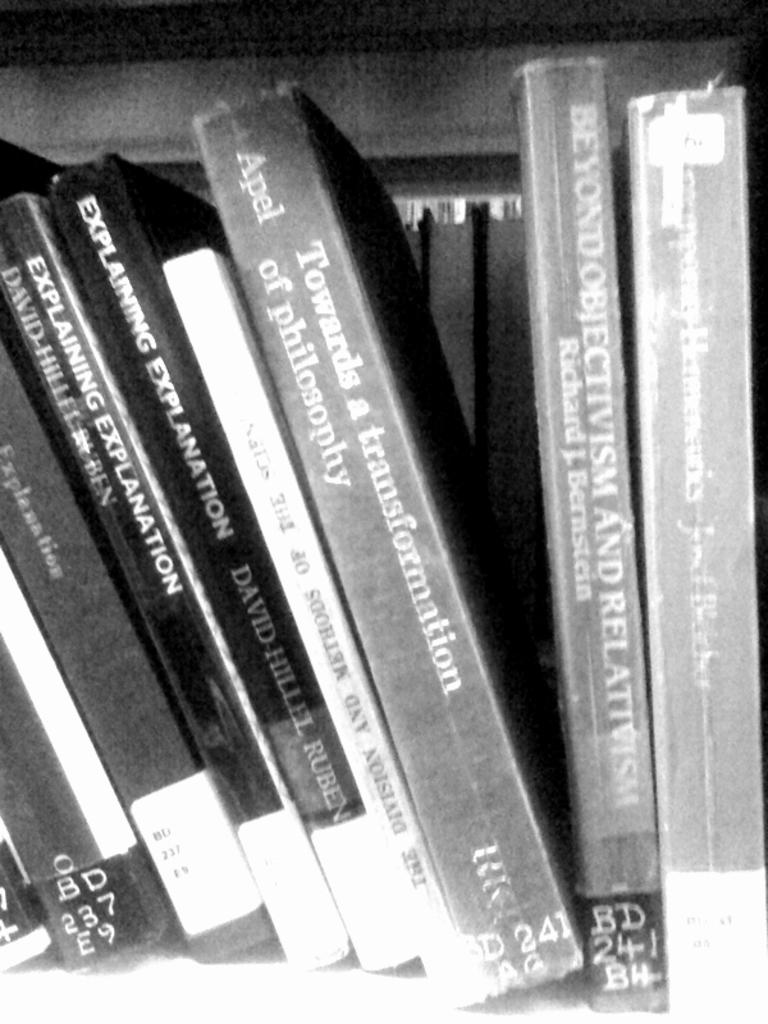<image>
Summarize the visual content of the image. "Towards a Transformation of Philosophy " book in between some other books on a shelf. 